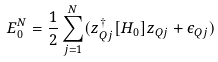<formula> <loc_0><loc_0><loc_500><loc_500>E _ { 0 } ^ { N } = \frac { 1 } { 2 } \sum _ { j = 1 } ^ { N } ( z _ { Q j } ^ { \dagger } [ H _ { 0 } ] z _ { Q j } + \epsilon _ { Q j } )</formula> 